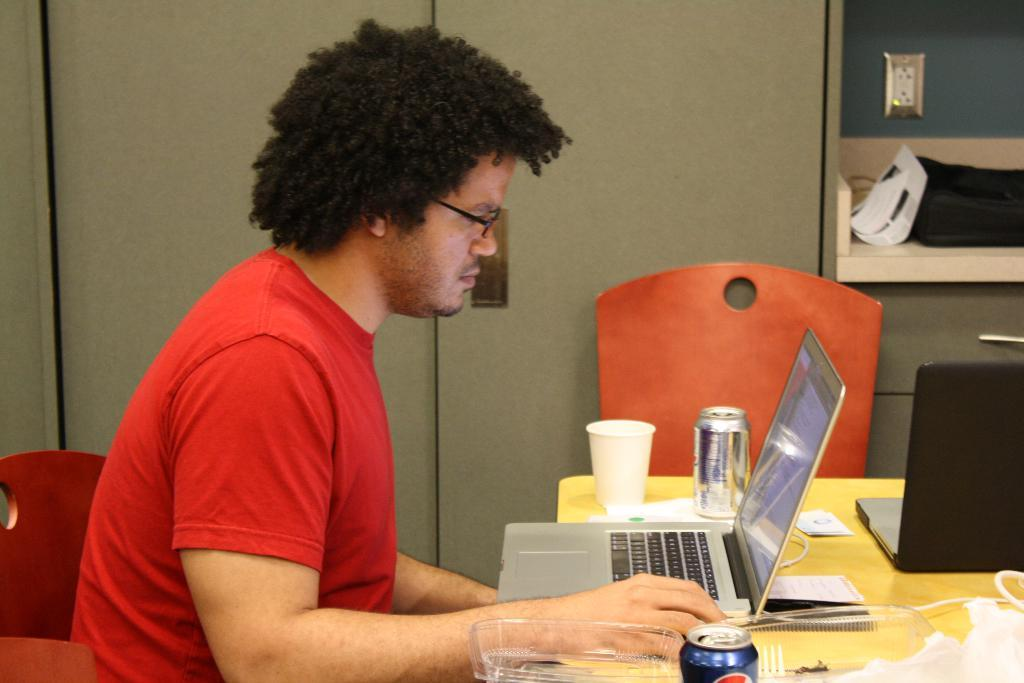What is the man in the image doing? The man is sitting and watching a laptop in the image. What is on the table in the image? There are two laptops, coke tins, a tumbler, and some objects on the table in the image. Can you describe the chair in the image? There is an empty chair in the image. What is the purpose of the rack in the image? The purpose of the rack in the image is not specified, but it could be used for storage or display. How many beetles can be seen crawling on the laptops in the image? There are no beetles present in the image. Can you describe the type of cart used to transport the table in the image? There is no cart present in the image. 